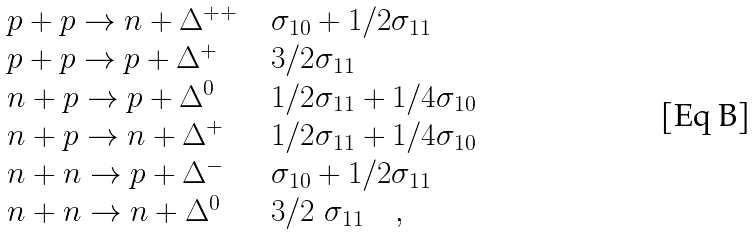Convert formula to latex. <formula><loc_0><loc_0><loc_500><loc_500>\begin{array} { l c l } p + p \rightarrow n + \Delta ^ { + + } & & \sigma _ { 1 0 } + 1 / 2 \sigma _ { 1 1 } \\ p + p \rightarrow p + \Delta ^ { + } & & 3 / 2 \sigma _ { 1 1 } \\ n + p \rightarrow p + \Delta ^ { 0 } & & 1 / 2 \sigma _ { 1 1 } + 1 / 4 \sigma _ { 1 0 } \\ n + p \rightarrow n + \Delta ^ { + } & & 1 / 2 \sigma _ { 1 1 } + 1 / 4 \sigma _ { 1 0 } \\ n + n \rightarrow p + \Delta ^ { - } & & \sigma _ { 1 0 } + 1 / 2 \sigma _ { 1 1 } \\ n + n \rightarrow n + \Delta ^ { 0 } & & 3 / 2 \ \sigma _ { 1 1 } \quad , \end{array}</formula> 